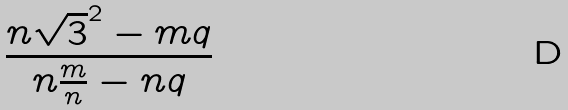<formula> <loc_0><loc_0><loc_500><loc_500>\frac { n \sqrt { 3 } ^ { 2 } - m q } { n \frac { m } { n } - n q }</formula> 